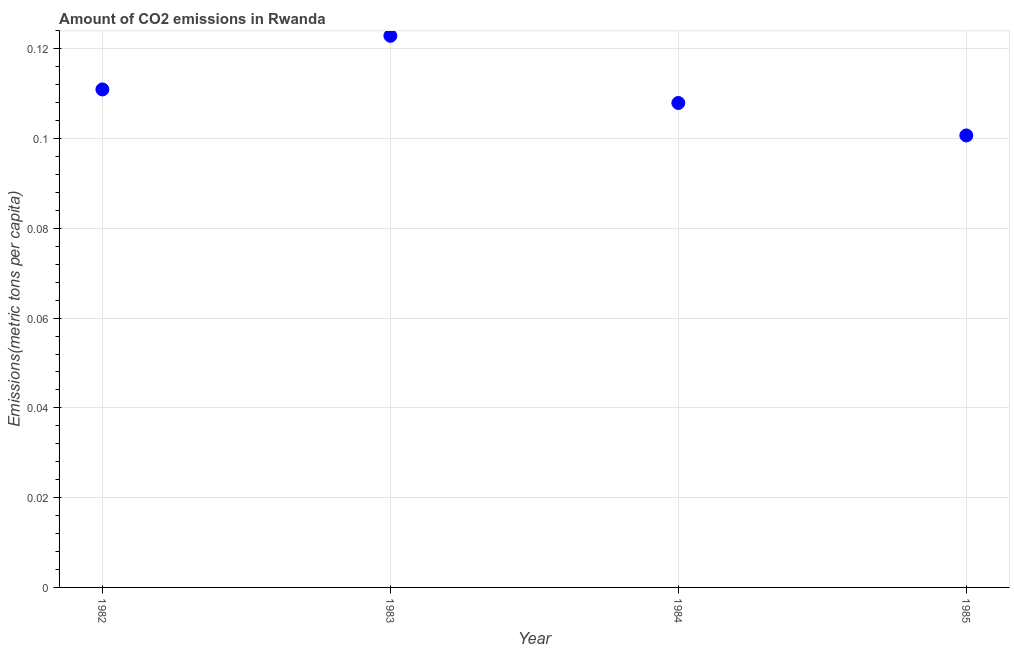What is the amount of co2 emissions in 1984?
Ensure brevity in your answer.  0.11. Across all years, what is the maximum amount of co2 emissions?
Make the answer very short. 0.12. Across all years, what is the minimum amount of co2 emissions?
Ensure brevity in your answer.  0.1. What is the sum of the amount of co2 emissions?
Provide a succinct answer. 0.44. What is the difference between the amount of co2 emissions in 1983 and 1984?
Give a very brief answer. 0.01. What is the average amount of co2 emissions per year?
Your answer should be very brief. 0.11. What is the median amount of co2 emissions?
Ensure brevity in your answer.  0.11. What is the ratio of the amount of co2 emissions in 1983 to that in 1985?
Ensure brevity in your answer.  1.22. Is the amount of co2 emissions in 1983 less than that in 1984?
Give a very brief answer. No. What is the difference between the highest and the second highest amount of co2 emissions?
Your answer should be very brief. 0.01. What is the difference between the highest and the lowest amount of co2 emissions?
Keep it short and to the point. 0.02. Does the amount of co2 emissions monotonically increase over the years?
Give a very brief answer. No. How many dotlines are there?
Ensure brevity in your answer.  1. How many years are there in the graph?
Provide a succinct answer. 4. Are the values on the major ticks of Y-axis written in scientific E-notation?
Offer a terse response. No. Does the graph contain any zero values?
Ensure brevity in your answer.  No. What is the title of the graph?
Provide a succinct answer. Amount of CO2 emissions in Rwanda. What is the label or title of the X-axis?
Your answer should be very brief. Year. What is the label or title of the Y-axis?
Ensure brevity in your answer.  Emissions(metric tons per capita). What is the Emissions(metric tons per capita) in 1982?
Keep it short and to the point. 0.11. What is the Emissions(metric tons per capita) in 1983?
Give a very brief answer. 0.12. What is the Emissions(metric tons per capita) in 1984?
Your answer should be compact. 0.11. What is the Emissions(metric tons per capita) in 1985?
Offer a terse response. 0.1. What is the difference between the Emissions(metric tons per capita) in 1982 and 1983?
Keep it short and to the point. -0.01. What is the difference between the Emissions(metric tons per capita) in 1982 and 1984?
Your answer should be compact. 0. What is the difference between the Emissions(metric tons per capita) in 1982 and 1985?
Offer a terse response. 0.01. What is the difference between the Emissions(metric tons per capita) in 1983 and 1984?
Provide a short and direct response. 0.01. What is the difference between the Emissions(metric tons per capita) in 1983 and 1985?
Keep it short and to the point. 0.02. What is the difference between the Emissions(metric tons per capita) in 1984 and 1985?
Ensure brevity in your answer.  0.01. What is the ratio of the Emissions(metric tons per capita) in 1982 to that in 1983?
Offer a very short reply. 0.9. What is the ratio of the Emissions(metric tons per capita) in 1982 to that in 1984?
Make the answer very short. 1.03. What is the ratio of the Emissions(metric tons per capita) in 1982 to that in 1985?
Your answer should be compact. 1.1. What is the ratio of the Emissions(metric tons per capita) in 1983 to that in 1984?
Provide a succinct answer. 1.14. What is the ratio of the Emissions(metric tons per capita) in 1983 to that in 1985?
Provide a succinct answer. 1.22. What is the ratio of the Emissions(metric tons per capita) in 1984 to that in 1985?
Make the answer very short. 1.07. 